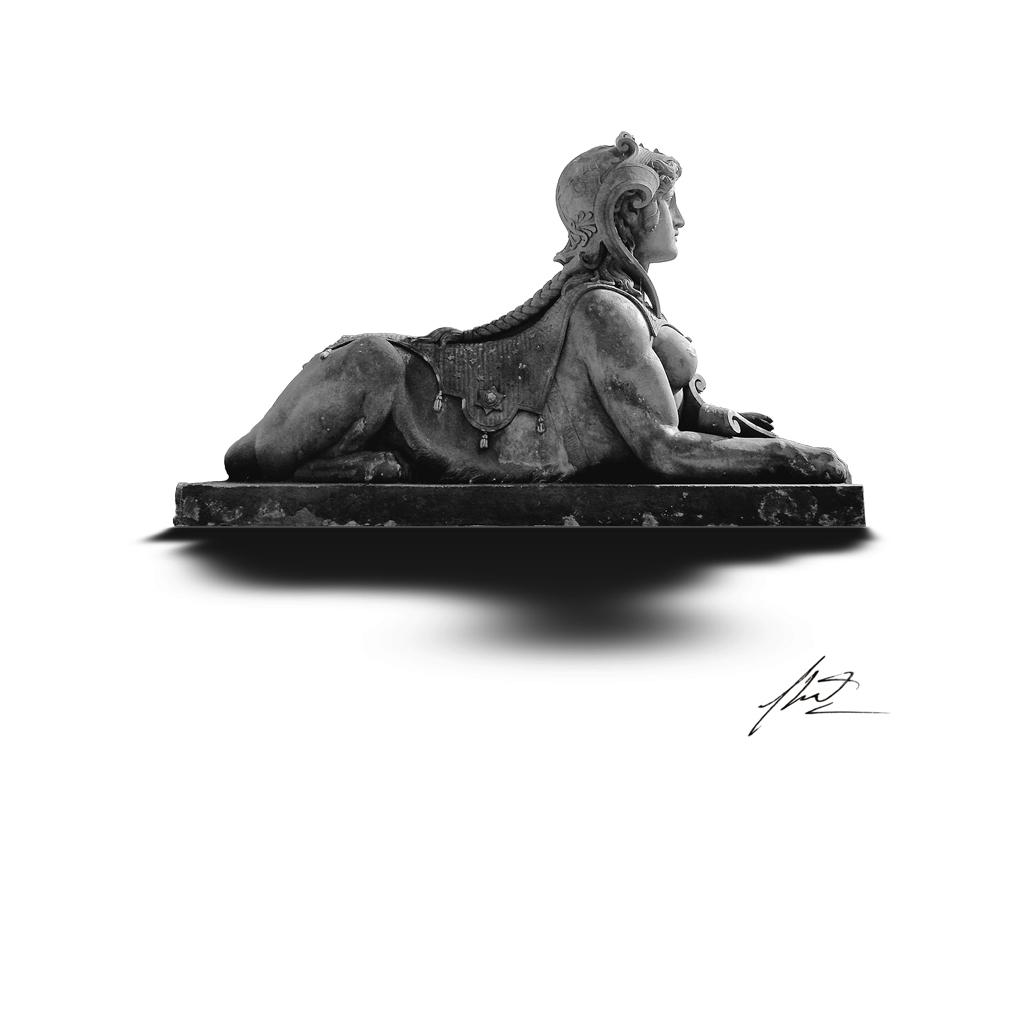What is the main subject of the image? There is a sculpture in the image. What shape is the sack that the sculpture is holding in the image? There is no sack present in the image, and the sculpture is not holding anything. 